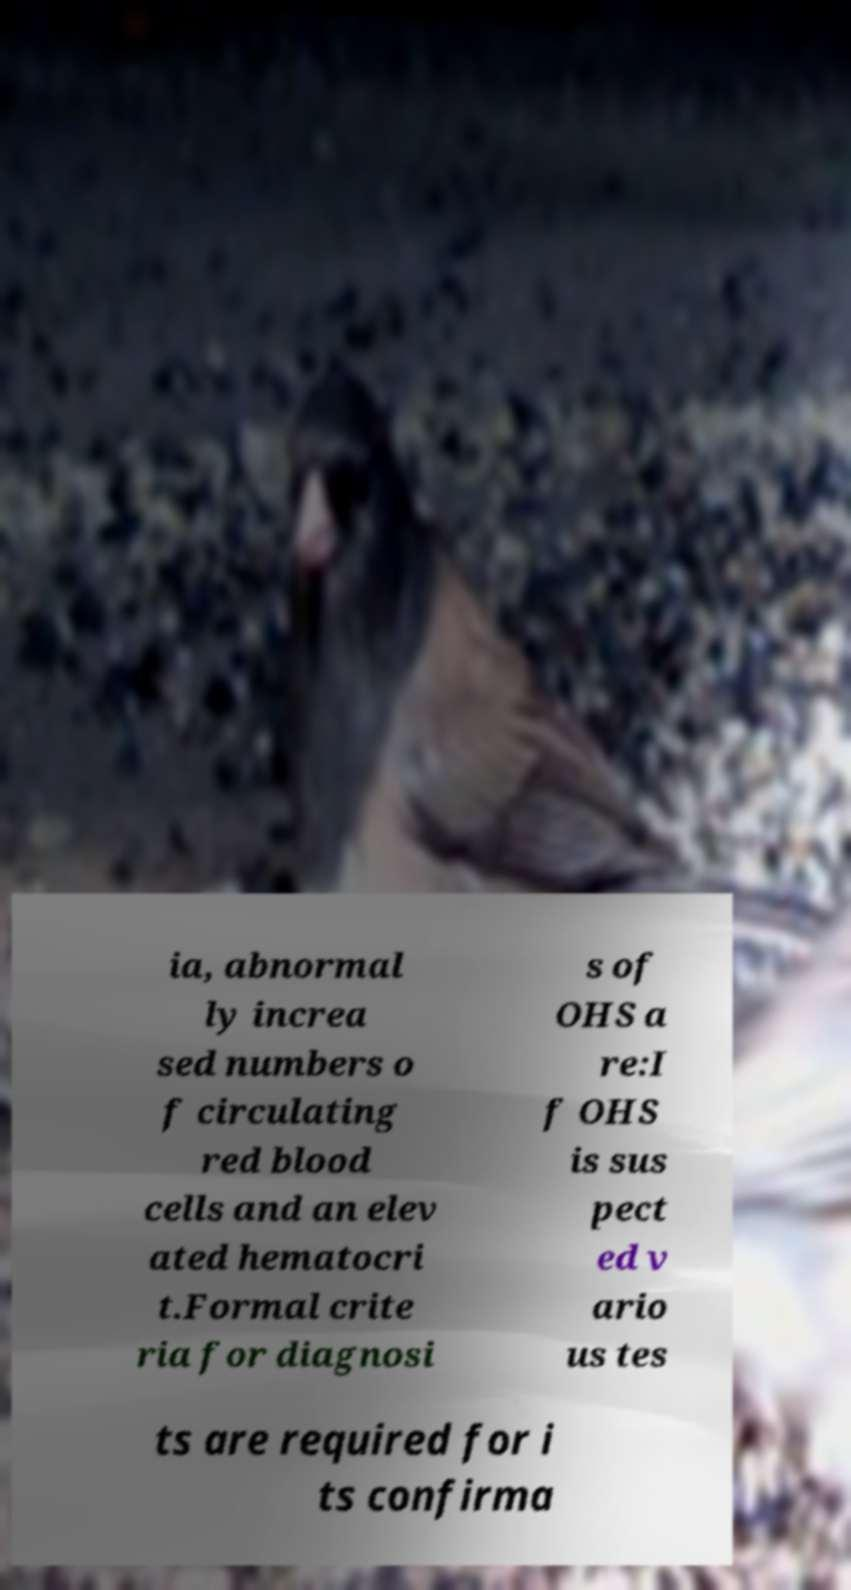I need the written content from this picture converted into text. Can you do that? ia, abnormal ly increa sed numbers o f circulating red blood cells and an elev ated hematocri t.Formal crite ria for diagnosi s of OHS a re:I f OHS is sus pect ed v ario us tes ts are required for i ts confirma 